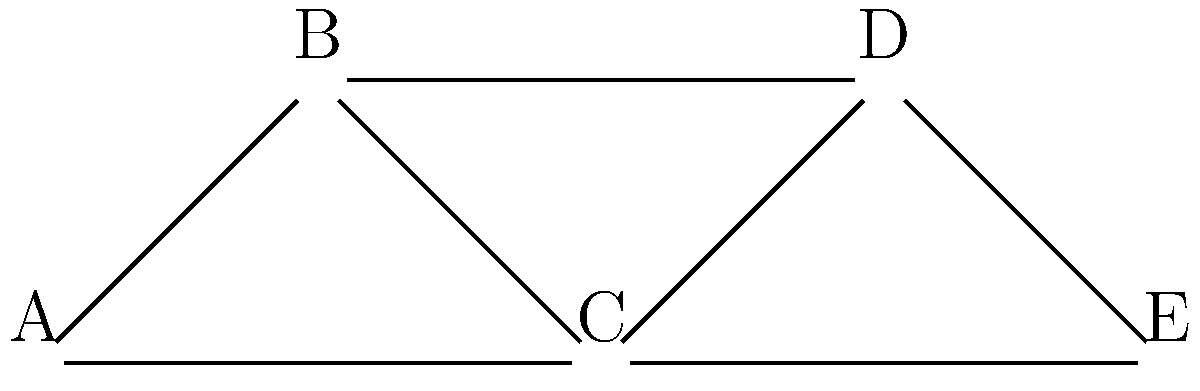In the co-authorship network shown above, authors are represented by nodes, and collaborations between authors are represented by edges. Which author has the highest degree centrality, indicating they have collaborated with the most other authors? To determine which author has the highest degree centrality, we need to count the number of edges connected to each node:

1. Author A: Connected to B and C (2 edges)
2. Author B: Connected to A, C, and D (3 edges)
3. Author C: Connected to A, B, D, and E (4 edges)
4. Author D: Connected to B, C, and E (3 edges)
5. Author E: Connected to C and D (2 edges)

Author C has the highest number of connections (4), which means they have collaborated with the most other authors in this network.

In network analysis, degree centrality is a measure of how many direct connections a node has to other nodes. In this context, it represents how many co-authors an author has worked with.

A high degree centrality in a co-authorship network can indicate that an author is highly collaborative, influential in their field, or works on interdisciplinary projects that bring together different experts.
Answer: C 